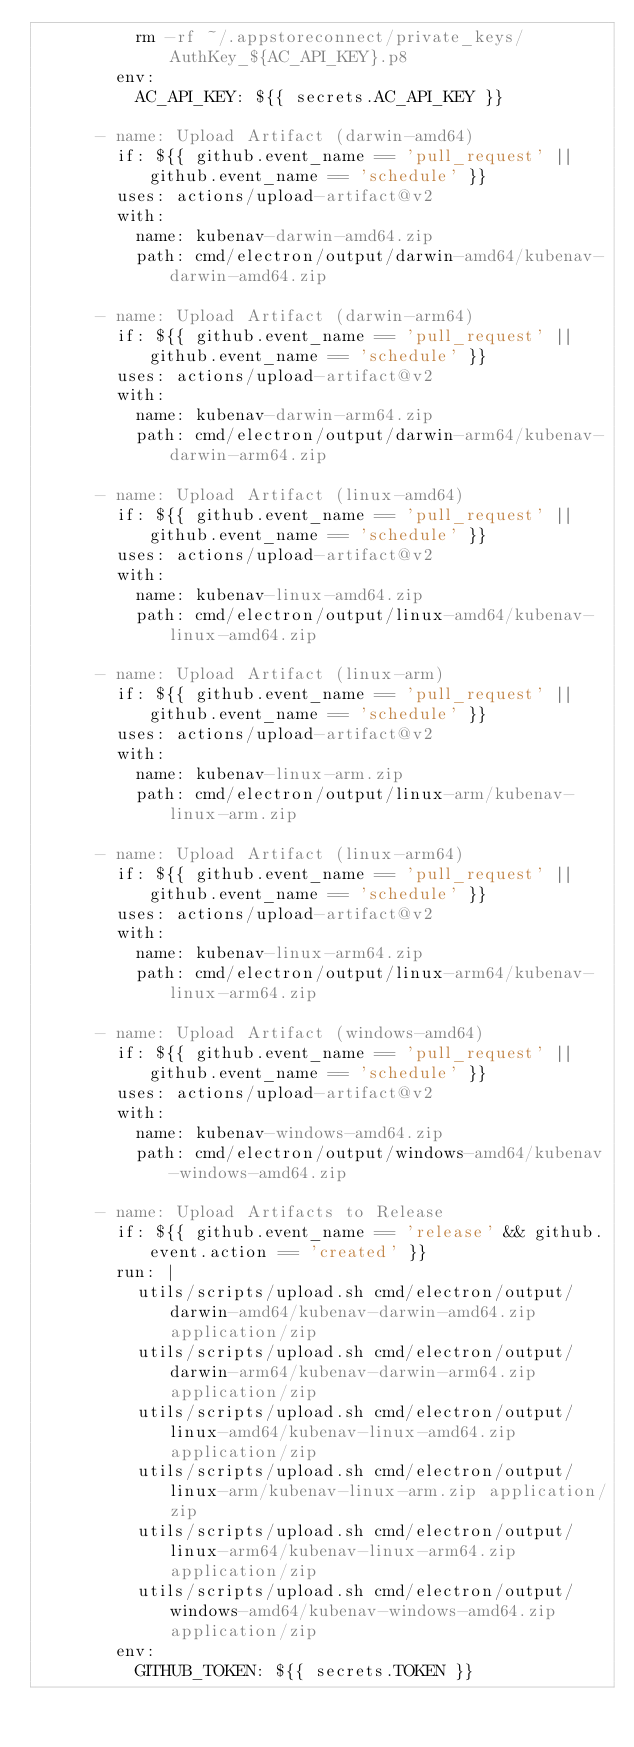Convert code to text. <code><loc_0><loc_0><loc_500><loc_500><_YAML_>          rm -rf ~/.appstoreconnect/private_keys/AuthKey_${AC_API_KEY}.p8
        env:
          AC_API_KEY: ${{ secrets.AC_API_KEY }}

      - name: Upload Artifact (darwin-amd64)
        if: ${{ github.event_name == 'pull_request' || github.event_name == 'schedule' }}
        uses: actions/upload-artifact@v2
        with:
          name: kubenav-darwin-amd64.zip
          path: cmd/electron/output/darwin-amd64/kubenav-darwin-amd64.zip

      - name: Upload Artifact (darwin-arm64)
        if: ${{ github.event_name == 'pull_request' || github.event_name == 'schedule' }}
        uses: actions/upload-artifact@v2
        with:
          name: kubenav-darwin-arm64.zip
          path: cmd/electron/output/darwin-arm64/kubenav-darwin-arm64.zip

      - name: Upload Artifact (linux-amd64)
        if: ${{ github.event_name == 'pull_request' || github.event_name == 'schedule' }}
        uses: actions/upload-artifact@v2
        with:
          name: kubenav-linux-amd64.zip
          path: cmd/electron/output/linux-amd64/kubenav-linux-amd64.zip

      - name: Upload Artifact (linux-arm)
        if: ${{ github.event_name == 'pull_request' || github.event_name == 'schedule' }}
        uses: actions/upload-artifact@v2
        with:
          name: kubenav-linux-arm.zip
          path: cmd/electron/output/linux-arm/kubenav-linux-arm.zip

      - name: Upload Artifact (linux-arm64)
        if: ${{ github.event_name == 'pull_request' || github.event_name == 'schedule' }}
        uses: actions/upload-artifact@v2
        with:
          name: kubenav-linux-arm64.zip
          path: cmd/electron/output/linux-arm64/kubenav-linux-arm64.zip

      - name: Upload Artifact (windows-amd64)
        if: ${{ github.event_name == 'pull_request' || github.event_name == 'schedule' }}
        uses: actions/upload-artifact@v2
        with:
          name: kubenav-windows-amd64.zip
          path: cmd/electron/output/windows-amd64/kubenav-windows-amd64.zip

      - name: Upload Artifacts to Release
        if: ${{ github.event_name == 'release' && github.event.action == 'created' }}
        run: |
          utils/scripts/upload.sh cmd/electron/output/darwin-amd64/kubenav-darwin-amd64.zip application/zip
          utils/scripts/upload.sh cmd/electron/output/darwin-arm64/kubenav-darwin-arm64.zip application/zip
          utils/scripts/upload.sh cmd/electron/output/linux-amd64/kubenav-linux-amd64.zip application/zip
          utils/scripts/upload.sh cmd/electron/output/linux-arm/kubenav-linux-arm.zip application/zip
          utils/scripts/upload.sh cmd/electron/output/linux-arm64/kubenav-linux-arm64.zip application/zip
          utils/scripts/upload.sh cmd/electron/output/windows-amd64/kubenav-windows-amd64.zip application/zip
        env:
          GITHUB_TOKEN: ${{ secrets.TOKEN }}
</code> 